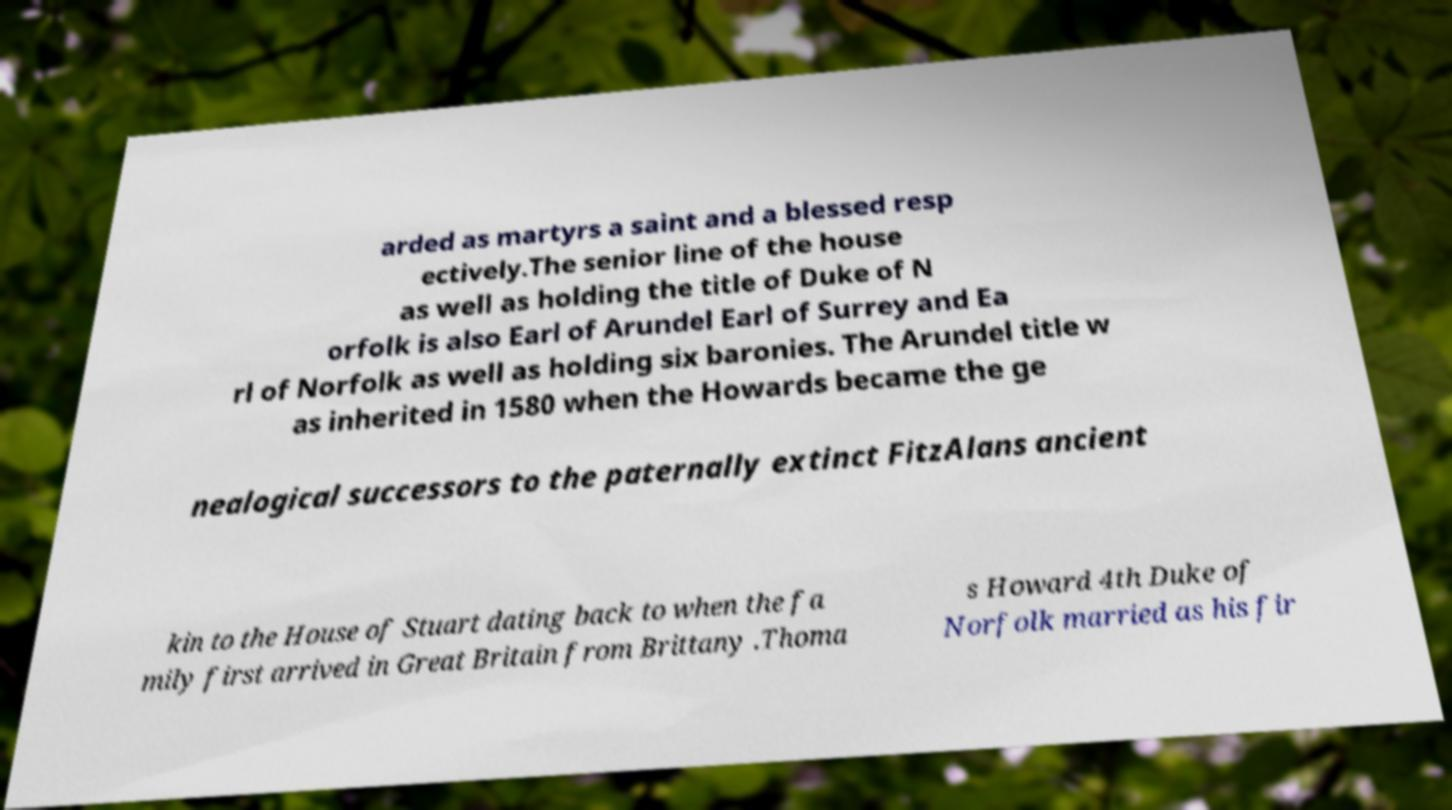There's text embedded in this image that I need extracted. Can you transcribe it verbatim? arded as martyrs a saint and a blessed resp ectively.The senior line of the house as well as holding the title of Duke of N orfolk is also Earl of Arundel Earl of Surrey and Ea rl of Norfolk as well as holding six baronies. The Arundel title w as inherited in 1580 when the Howards became the ge nealogical successors to the paternally extinct FitzAlans ancient kin to the House of Stuart dating back to when the fa mily first arrived in Great Britain from Brittany .Thoma s Howard 4th Duke of Norfolk married as his fir 